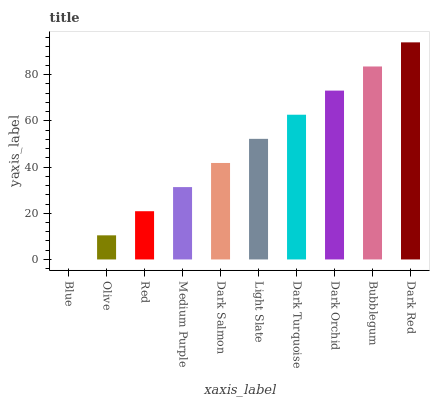Is Blue the minimum?
Answer yes or no. Yes. Is Dark Red the maximum?
Answer yes or no. Yes. Is Olive the minimum?
Answer yes or no. No. Is Olive the maximum?
Answer yes or no. No. Is Olive greater than Blue?
Answer yes or no. Yes. Is Blue less than Olive?
Answer yes or no. Yes. Is Blue greater than Olive?
Answer yes or no. No. Is Olive less than Blue?
Answer yes or no. No. Is Light Slate the high median?
Answer yes or no. Yes. Is Dark Salmon the low median?
Answer yes or no. Yes. Is Red the high median?
Answer yes or no. No. Is Dark Orchid the low median?
Answer yes or no. No. 